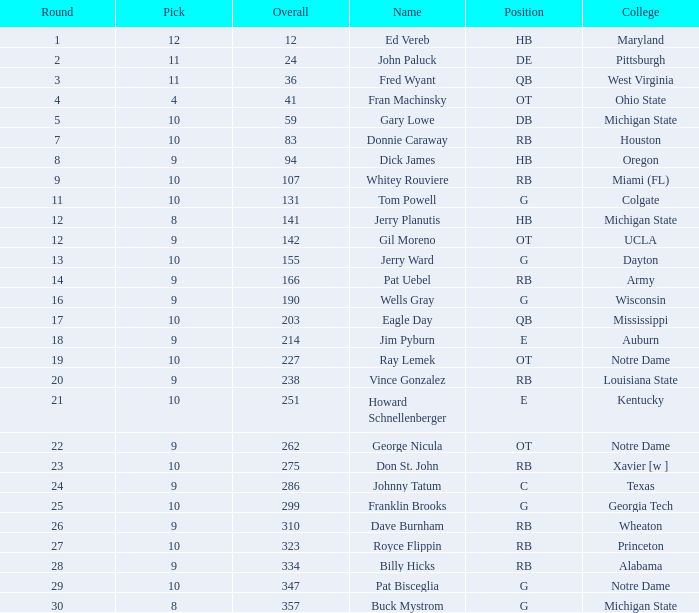What is the sum of all choices made after pick 9 and directed towards auburn college? 0.0. 